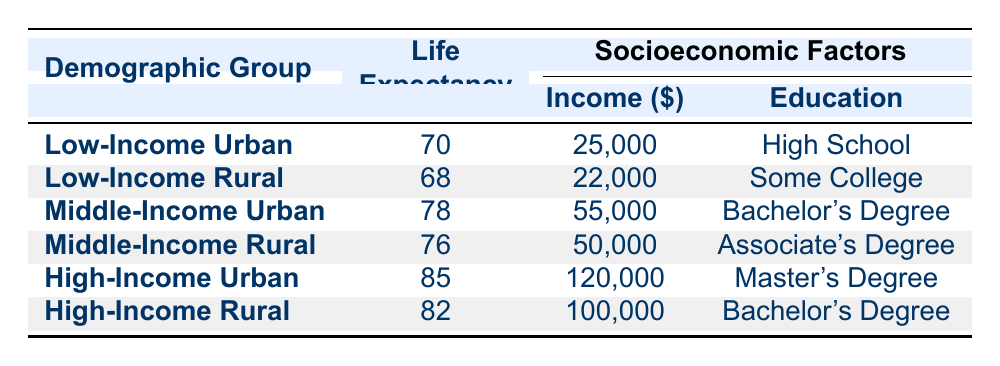What is the average life expectancy for the High-Income Urban demographic group? The table indicates that the High-Income Urban demographic group has an average life expectancy of 85 years.
Answer: 85 Which demographic group has the lowest average income? By comparing the average incomes listed, the Low-Income Rural group has the lowest average income at $22,000.
Answer: Low-Income Rural What is the difference in average life expectancy between Middle-Income Urban and Low-Income Rural groups? The average life expectancy for Middle-Income Urban is 78 years, and for Low-Income Rural, it is 68 years. The difference is 78 - 68 = 10 years.
Answer: 10 Is it true that individuals in the High-Income Rural demographic have better healthcare access than those in the Low-Income Urban group? The table shows that High-Income Rural has "Good" healthcare access, while Low-Income Urban has "Limited" access. Since "Good" is better than "Limited," the statement is true.
Answer: Yes What is the average life expectancy for all demographic groups combined? To find the average, we add the life expectancies: 70 + 68 + 78 + 76 + 85 + 82 = 459. There are 6 groups, so the average is 459/6 = 76.5.
Answer: 76.5 